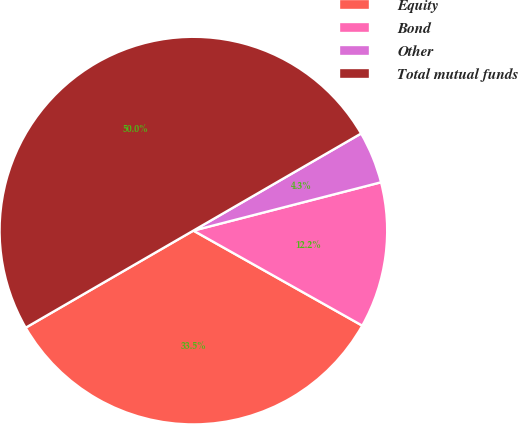Convert chart to OTSL. <chart><loc_0><loc_0><loc_500><loc_500><pie_chart><fcel>Equity<fcel>Bond<fcel>Other<fcel>Total mutual funds<nl><fcel>33.49%<fcel>12.17%<fcel>4.34%<fcel>50.0%<nl></chart> 